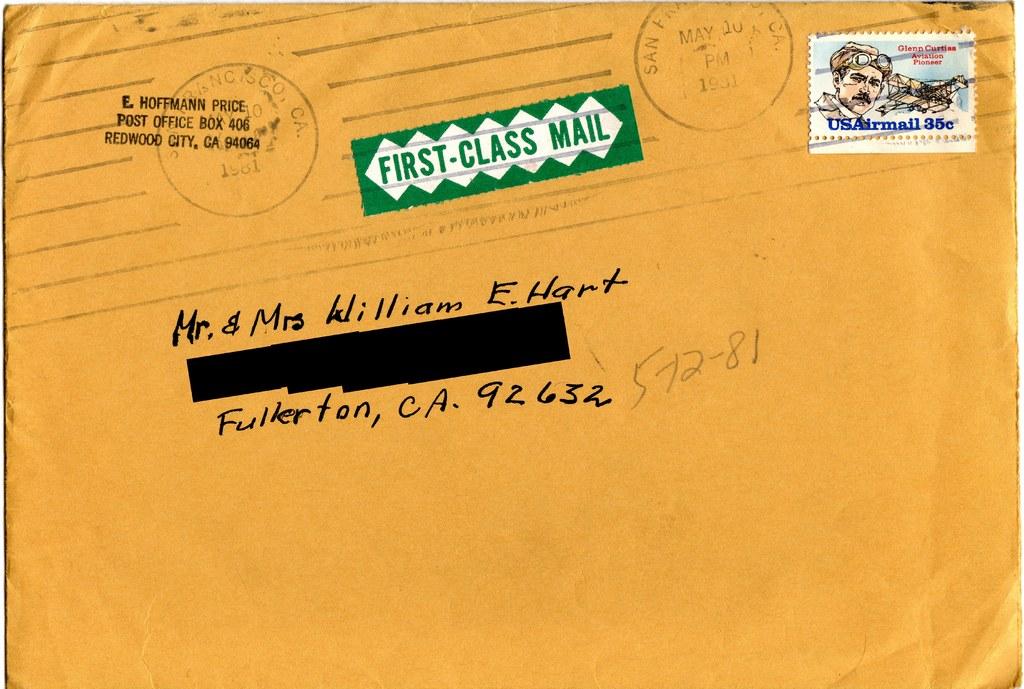What class mail is this?
Your response must be concise. First. What is the name of the city?
Offer a very short reply. Fullerton. 